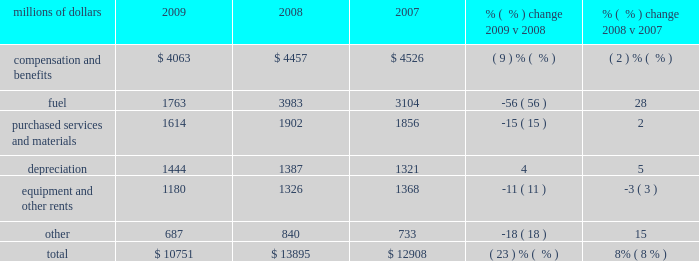Intermodal 2013 decreased volumes and fuel surcharges reduced freight revenue from intermodal shipments in 2009 versus 2008 .
Volume from international traffic decreased 24% ( 24 % ) in 2009 compared to 2008 , reflecting economic conditions , continued weak imports from asia , and diversions to non-uprr served ports .
Additionally , continued weakness in the domestic housing and automotive sectors translated into weak demand in large sectors of the international intermodal market , which also contributed to the volume decline .
Conversely , domestic traffic increased 8% ( 8 % ) in 2009 compared to 2008 .
A new contract with hub group , inc. , which included additional shipments , was executed in the second quarter of 2009 and more than offset the impact of weak market conditions in the second half of 2009 .
Price increases and fuel surcharges generated higher revenue in 2008 , partially offset by lower volume levels .
International traffic declined 11% ( 11 % ) in 2008 , reflecting continued softening of imports from china and the loss of a customer contract .
Notably , the peak intermodal shipping season , which usually starts in the third quarter , was particularly weak in 2008 .
Additionally , continued weakness in domestic housing and automotive sectors translated into weak demand in large sectors of the international intermodal market , which also contributed to lower volumes .
Domestic traffic declined 3% ( 3 % ) in 2008 due to the loss of a customer contract and lower volumes from less-than-truckload shippers .
Additionally , the flood-related embargo on traffic in the midwest during the second quarter hindered intermodal volume levels in 2008 .
Mexico business 2013 each of our commodity groups include revenue from shipments to and from mexico .
Revenue from mexico business decreased 26% ( 26 % ) in 2009 versus 2008 to $ 1.2 billion .
Volume declined in five of our six commodity groups , down 19% ( 19 % ) in 2009 , driven by 32% ( 32 % ) and 24% ( 24 % ) reductions in industrial products and automotive shipments , respectively .
Conversely , energy shipments increased 9% ( 9 % ) in 2009 versus 2008 , partially offsetting these declines .
Revenue from mexico business increased 13% ( 13 % ) to $ 1.6 billion in 2008 compared to 2007 .
Price improvements and fuel surcharges contributed to these increases , partially offset by a 4% ( 4 % ) decline in volume in 2008 compared to 2007 .
Operating expenses millions of dollars 2009 2008 2007 % (  % ) change 2009 v 2008 % (  % ) change 2008 v 2007 .
2009 intermodal revenue international domestic .
What was the average yearly decline in international traffic in 2008 and in 2009? 
Computations: ((11% + 24%) / 2)
Answer: 0.175. 